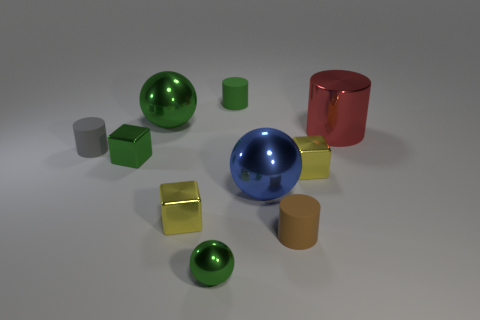The other sphere that is the same color as the small metal sphere is what size?
Keep it short and to the point. Large. Does the gray thing have the same material as the tiny brown cylinder?
Your answer should be very brief. Yes. What is the color of the small cylinder that is left of the yellow metallic thing that is in front of the yellow cube to the right of the brown cylinder?
Your response must be concise. Gray. The big green metal object has what shape?
Offer a terse response. Sphere. Do the tiny metal ball and the big object that is left of the green matte cylinder have the same color?
Offer a very short reply. Yes. Are there the same number of blue metallic balls that are right of the tiny brown cylinder and large blue objects?
Your answer should be very brief. No. What number of red shiny balls are the same size as the green matte cylinder?
Your answer should be compact. 0. There is a small matte thing that is the same color as the small shiny ball; what shape is it?
Provide a succinct answer. Cylinder. Are any big green metallic cylinders visible?
Give a very brief answer. No. There is a yellow metallic object that is to the left of the blue shiny sphere; does it have the same shape as the yellow metal object on the right side of the green rubber cylinder?
Keep it short and to the point. Yes. 